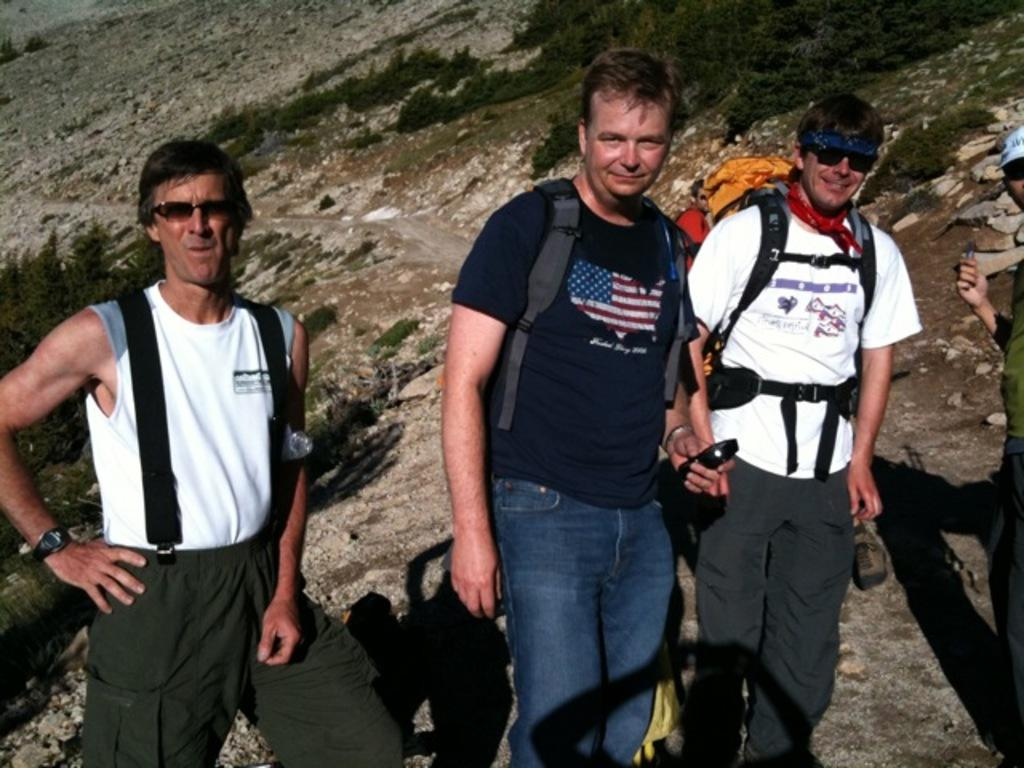How many people are in the image? There are people in the image, but the exact number is not specified. What are the people wearing in the image? The people are wearing bags in the image. What object is one of the people holding? One of the people is holding a mobile in the image. What can be seen in the background of the image? There are trees and hills in the background of the image. What type of authority do the people in the image have? There is no information about the authority of the people in the image. How many feet are visible in the image? The number of feet visible in the image is not mentioned in the facts. Are there any ducks present in the image? There is no mention of ducks in the image. 